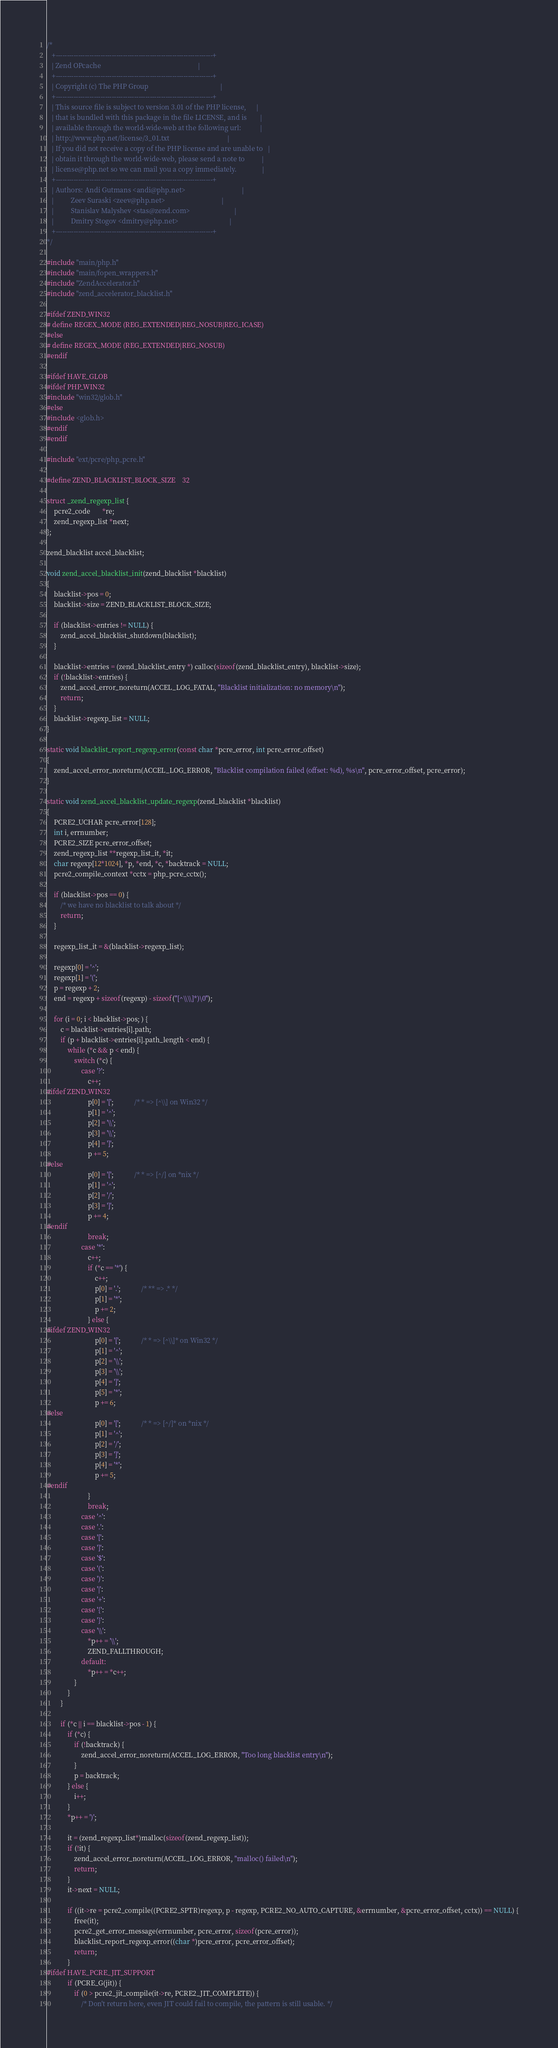Convert code to text. <code><loc_0><loc_0><loc_500><loc_500><_C_>/*
   +----------------------------------------------------------------------+
   | Zend OPcache                                                         |
   +----------------------------------------------------------------------+
   | Copyright (c) The PHP Group                                          |
   +----------------------------------------------------------------------+
   | This source file is subject to version 3.01 of the PHP license,      |
   | that is bundled with this package in the file LICENSE, and is        |
   | available through the world-wide-web at the following url:           |
   | http://www.php.net/license/3_01.txt                                  |
   | If you did not receive a copy of the PHP license and are unable to   |
   | obtain it through the world-wide-web, please send a note to          |
   | license@php.net so we can mail you a copy immediately.               |
   +----------------------------------------------------------------------+
   | Authors: Andi Gutmans <andi@php.net>                                 |
   |          Zeev Suraski <zeev@php.net>                                 |
   |          Stanislav Malyshev <stas@zend.com>                          |
   |          Dmitry Stogov <dmitry@php.net>                              |
   +----------------------------------------------------------------------+
*/

#include "main/php.h"
#include "main/fopen_wrappers.h"
#include "ZendAccelerator.h"
#include "zend_accelerator_blacklist.h"

#ifdef ZEND_WIN32
# define REGEX_MODE (REG_EXTENDED|REG_NOSUB|REG_ICASE)
#else
# define REGEX_MODE (REG_EXTENDED|REG_NOSUB)
#endif

#ifdef HAVE_GLOB
#ifdef PHP_WIN32
#include "win32/glob.h"
#else
#include <glob.h>
#endif
#endif

#include "ext/pcre/php_pcre.h"

#define ZEND_BLACKLIST_BLOCK_SIZE	32

struct _zend_regexp_list {
	pcre2_code       *re;
	zend_regexp_list *next;
};

zend_blacklist accel_blacklist;

void zend_accel_blacklist_init(zend_blacklist *blacklist)
{
	blacklist->pos = 0;
	blacklist->size = ZEND_BLACKLIST_BLOCK_SIZE;

	if (blacklist->entries != NULL) {
		zend_accel_blacklist_shutdown(blacklist);
	}

	blacklist->entries = (zend_blacklist_entry *) calloc(sizeof(zend_blacklist_entry), blacklist->size);
	if (!blacklist->entries) {
		zend_accel_error_noreturn(ACCEL_LOG_FATAL, "Blacklist initialization: no memory\n");
		return;
	}
	blacklist->regexp_list = NULL;
}

static void blacklist_report_regexp_error(const char *pcre_error, int pcre_error_offset)
{
	zend_accel_error_noreturn(ACCEL_LOG_ERROR, "Blacklist compilation failed (offset: %d), %s\n", pcre_error_offset, pcre_error);
}

static void zend_accel_blacklist_update_regexp(zend_blacklist *blacklist)
{
	PCRE2_UCHAR pcre_error[128];
	int i, errnumber;
	PCRE2_SIZE pcre_error_offset;
	zend_regexp_list **regexp_list_it, *it;
	char regexp[12*1024], *p, *end, *c, *backtrack = NULL;
	pcre2_compile_context *cctx = php_pcre_cctx();

	if (blacklist->pos == 0) {
		/* we have no blacklist to talk about */
		return;
	}

	regexp_list_it = &(blacklist->regexp_list);

	regexp[0] = '^';
	regexp[1] = '(';
	p = regexp + 2;
	end = regexp + sizeof(regexp) - sizeof("[^\\\\]*)\0");

	for (i = 0; i < blacklist->pos; ) {
		c = blacklist->entries[i].path;
		if (p + blacklist->entries[i].path_length < end) {
			while (*c && p < end) {
				switch (*c) {
					case '?':
						c++;
#ifdef ZEND_WIN32
				 		p[0] = '[';			/* * => [^\\] on Win32 */
					 	p[1] = '^';
					 	p[2] = '\\';
					 	p[3] = '\\';
					 	p[4] = ']';
						p += 5;
#else
					 	p[0] = '[';			/* * => [^/] on *nix */
					 	p[1] = '^';
					 	p[2] = '/';
					 	p[3] = ']';
						p += 4;
#endif
						break;
					case '*':
						c++;
						if (*c == '*') {
							c++;
						 	p[0] = '.';			/* ** => .* */
							p[1] = '*';
							p += 2;
						} else {
#ifdef ZEND_WIN32
						 	p[0] = '[';			/* * => [^\\]* on Win32 */
						 	p[1] = '^';
						 	p[2] = '\\';
						 	p[3] = '\\';
						 	p[4] = ']';
						 	p[5] = '*';
							p += 6;
#else
						 	p[0] = '[';			/* * => [^/]* on *nix */
						 	p[1] = '^';
						 	p[2] = '/';
						 	p[3] = ']';
						 	p[4] = '*';
							p += 5;
#endif
						}
						break;
					case '^':
					case '.':
					case '[':
					case ']':
					case '$':
					case '(':
					case ')':
					case '|':
					case '+':
					case '{':
					case '}':
					case '\\':
						*p++ = '\\';
						ZEND_FALLTHROUGH;
					default:
						*p++ = *c++;
				}
			}
		}

		if (*c || i == blacklist->pos - 1) {
			if (*c) {
				if (!backtrack) {
					zend_accel_error_noreturn(ACCEL_LOG_ERROR, "Too long blacklist entry\n");
				}
				p = backtrack;
			} else {
				i++;
			}
			*p++ = ')';

			it = (zend_regexp_list*)malloc(sizeof(zend_regexp_list));
			if (!it) {
				zend_accel_error_noreturn(ACCEL_LOG_ERROR, "malloc() failed\n");
				return;
			}
			it->next = NULL;

			if ((it->re = pcre2_compile((PCRE2_SPTR)regexp, p - regexp, PCRE2_NO_AUTO_CAPTURE, &errnumber, &pcre_error_offset, cctx)) == NULL) {
				free(it);
				pcre2_get_error_message(errnumber, pcre_error, sizeof(pcre_error));
				blacklist_report_regexp_error((char *)pcre_error, pcre_error_offset);
				return;
			}
#ifdef HAVE_PCRE_JIT_SUPPORT
			if (PCRE_G(jit)) {
				if (0 > pcre2_jit_compile(it->re, PCRE2_JIT_COMPLETE)) {
					/* Don't return here, even JIT could fail to compile, the pattern is still usable. */</code> 